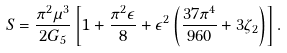Convert formula to latex. <formula><loc_0><loc_0><loc_500><loc_500>S = \frac { \pi ^ { 2 } \mu ^ { 3 } } { 2 G _ { 5 } } \left [ 1 + \frac { \pi ^ { 2 } \epsilon } { 8 } + \epsilon ^ { 2 } \left ( \frac { 3 7 \pi ^ { 4 } } { 9 6 0 } + 3 \zeta _ { 2 } \right ) \right ] .</formula> 